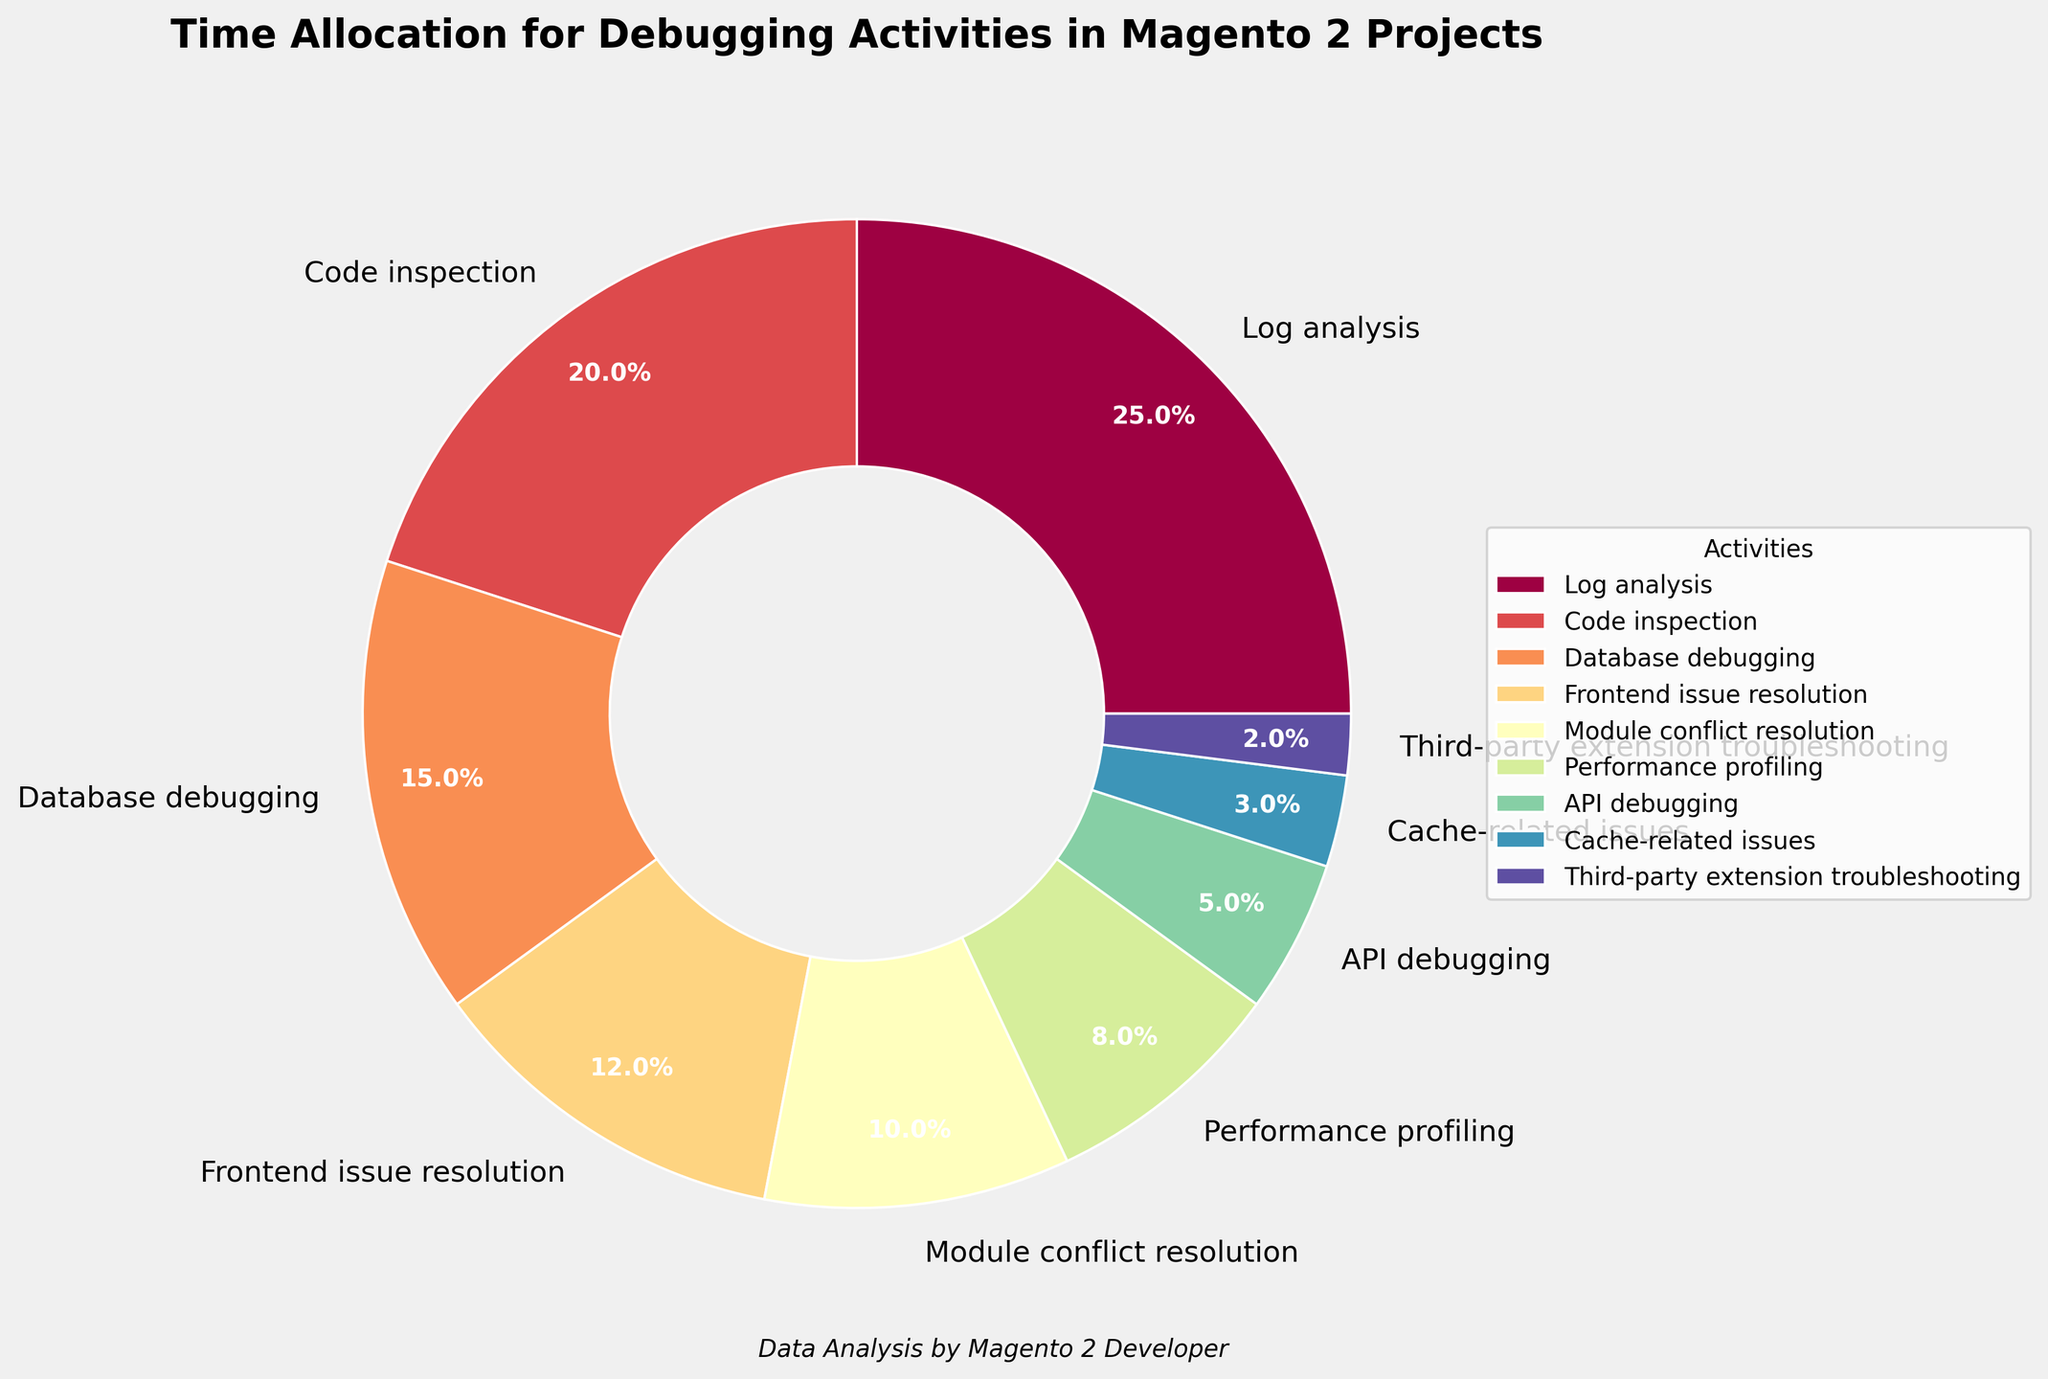What's the sum of the percentages for Log analysis and Code inspection? To find the sum, add the percentages of Log analysis (25%) and Code inspection (20%). 25 + 20 = 45.
Answer: 45% Which debugging activity has the smallest percentage allocation? Among all the activities listed, Third-party extension troubleshooting has the smallest percentage allocation of 2%.
Answer: Third-party extension troubleshooting Is the percentage allocation for Log analysis greater than Database debugging? Compare the percentages of Log analysis (25%) and Database debugging (15%). Since 25 is greater than 15, the allocation for Log analysis is indeed greater.
Answer: Yes What is the total percentage allocated to Cache-related issues and Performance profiling? Add the percentages for Cache-related issues (3%) and Performance profiling (8%). 3 + 8 = 11.
Answer: 11% Which activity's allocation is approximately double that of API debugging? API debugging has an allocation of 5%. The activity close to double this value is Log analysis at 25%.
Answer: Log analysis How much more time is allocated to Frontend issue resolution than to Third-party extension troubleshooting? Subtract the percentage for Third-party extension troubleshooting (2%) from Frontend issue resolution (12%). 12 - 2 = 10.
Answer: 10% What percentage of time is allocated to activities related to performance, i.e., Performance profiling and Cache-related issues, combined? Add the percentages for Performance profiling (8%) and Cache-related issues (3%). 8 + 3 = 11.
Answer: 11% Which activities together make up half of the total debugging time? Log analysis (25%) and Code inspection (20%) sum up to 45%. Adding Database debugging (15%) totals 60%. Next, try combinations lower than 60%. Log analysis (25%) and Database debugging (15%) alone won't add up. However, Code inspection (20%) and Database debugging (15%) do not either. Therefore, Log analysis and Frontend issue resolution (12%) make exactly half: 25 + 12 = 37, let's recheck, no sch match for exact half. None sum up to 50%.
Answer: None 